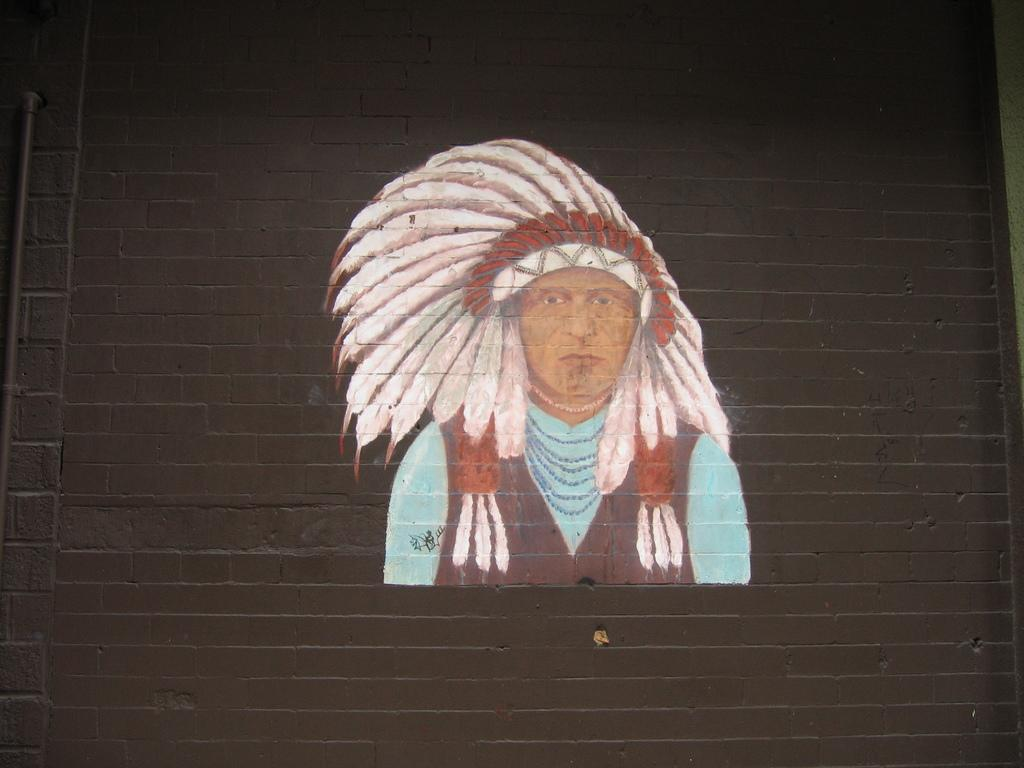What is present on the wall in the image? A painting is done on the wall in the image. Can you describe the painting on the wall? Unfortunately, the facts provided do not give any details about the painting. What is the primary purpose of the wall in the image? The primary purpose of the wall in the image is to support the painting. What type of juice is being served by the manager in the image? There is no manager or juice present in the image. The image only features a wall with a painting on it. 